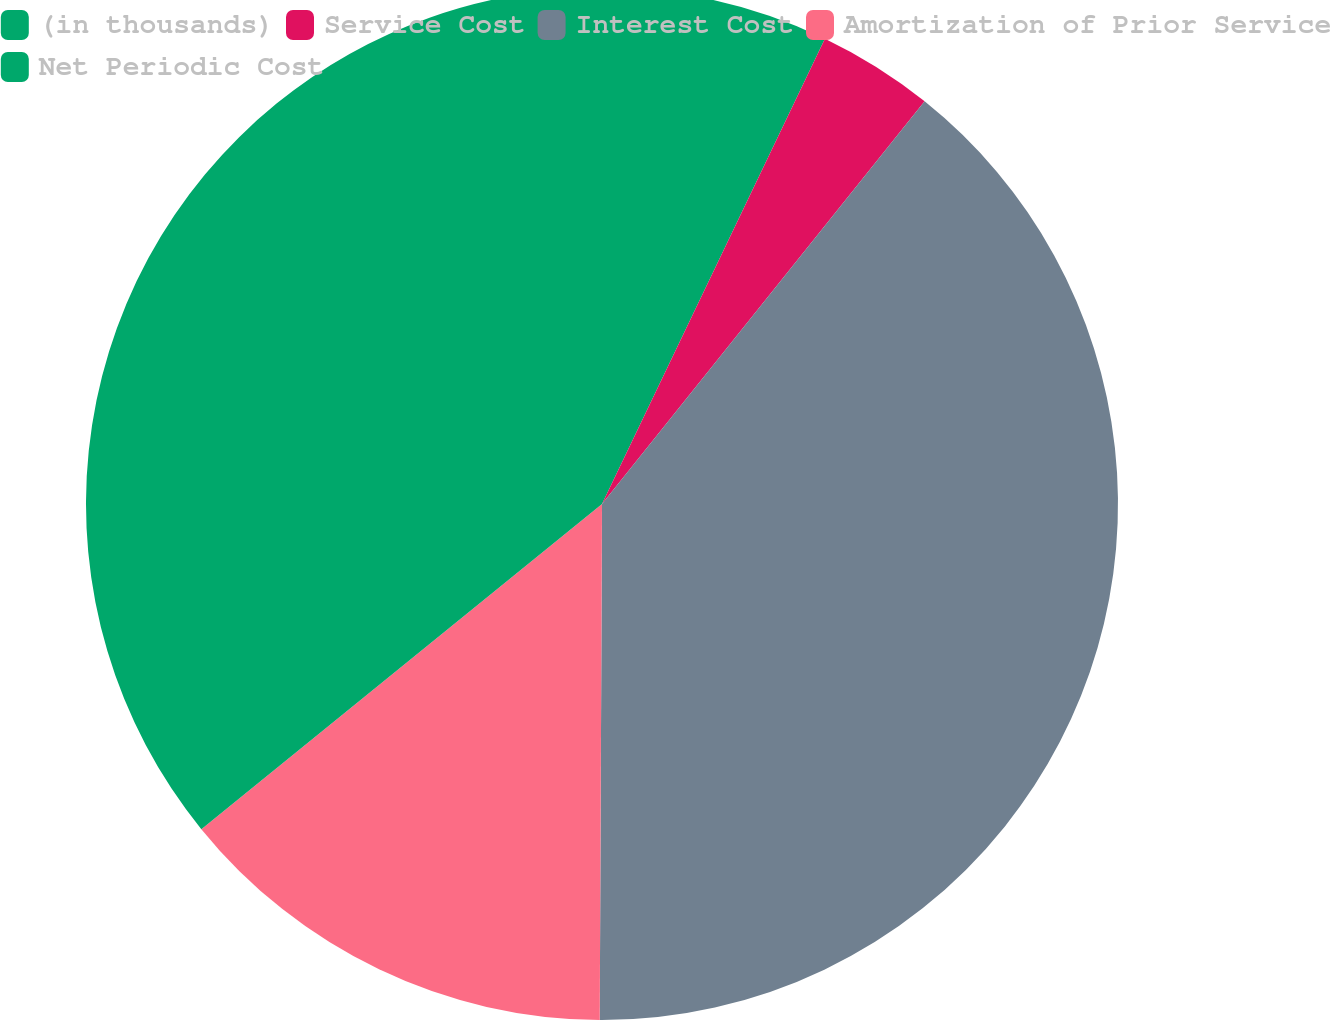<chart> <loc_0><loc_0><loc_500><loc_500><pie_chart><fcel>(in thousands)<fcel>Service Cost<fcel>Interest Cost<fcel>Amortization of Prior Service<fcel>Net Periodic Cost<nl><fcel>7.11%<fcel>3.64%<fcel>39.32%<fcel>14.08%<fcel>35.85%<nl></chart> 